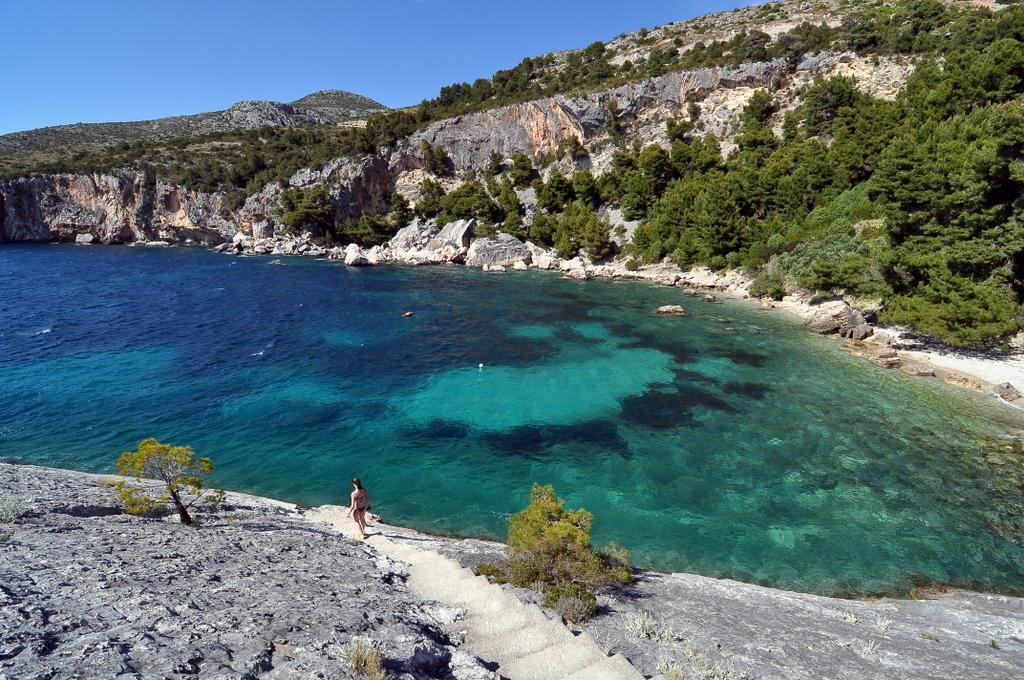What is one of the natural elements visible in the image? Water is visible in the image. What is the color of the sky in the image? The sky is blue in the image. What type of geological formation can be seen in the image? There are rocks in the image. What type of vegetation is present in the image? Trees are present in the image. What architectural feature is visible in the image? There are steps in the image. Can you describe the person visible in the image? A person is visible in the image, but their specific appearance or actions are not described in the provided facts. What type of cream is being poured into the harbor in the image? There is no harbor or cream present in the image. 